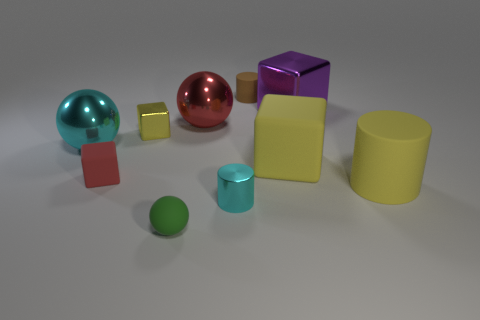Subtract 1 cylinders. How many cylinders are left? 2 Subtract all metal balls. How many balls are left? 1 Subtract all red cubes. How many cubes are left? 3 Subtract all gray cubes. Subtract all brown spheres. How many cubes are left? 4 Subtract all cyan blocks. How many green balls are left? 1 Subtract all small brown cylinders. Subtract all yellow matte objects. How many objects are left? 7 Add 1 purple metallic things. How many purple metallic things are left? 2 Add 4 balls. How many balls exist? 7 Subtract 1 red blocks. How many objects are left? 9 Subtract all cylinders. How many objects are left? 7 